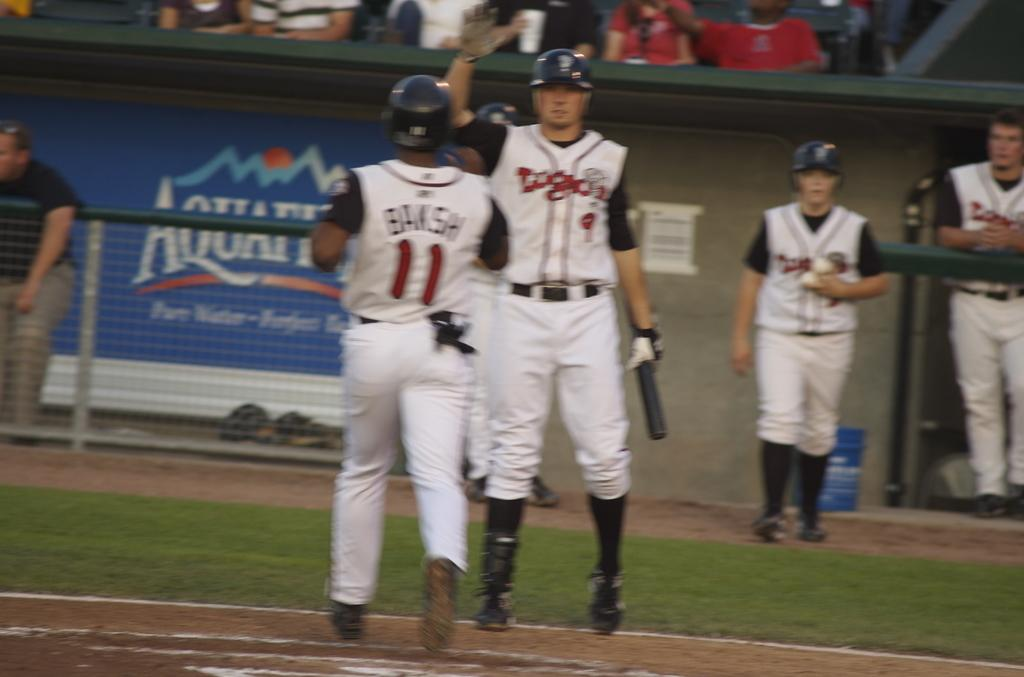<image>
Give a short and clear explanation of the subsequent image. A baseball team is giving each other high fives and their jerseys say Dodgers. 